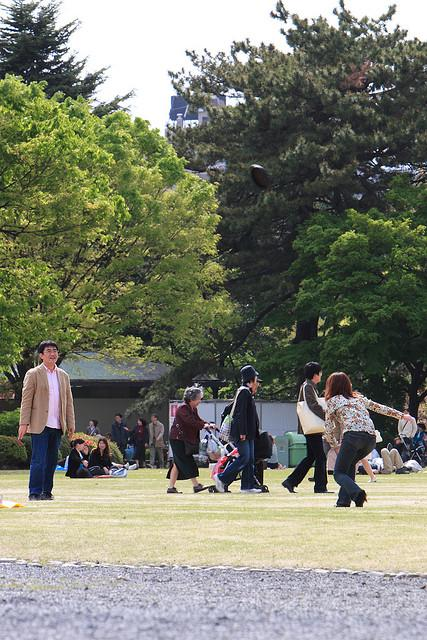What is the likely relation of the person pushing the stroller to the child in it? Please explain your reasoning. grandmother. There is a woman in grey hair pushing a stroller among others in a field. 